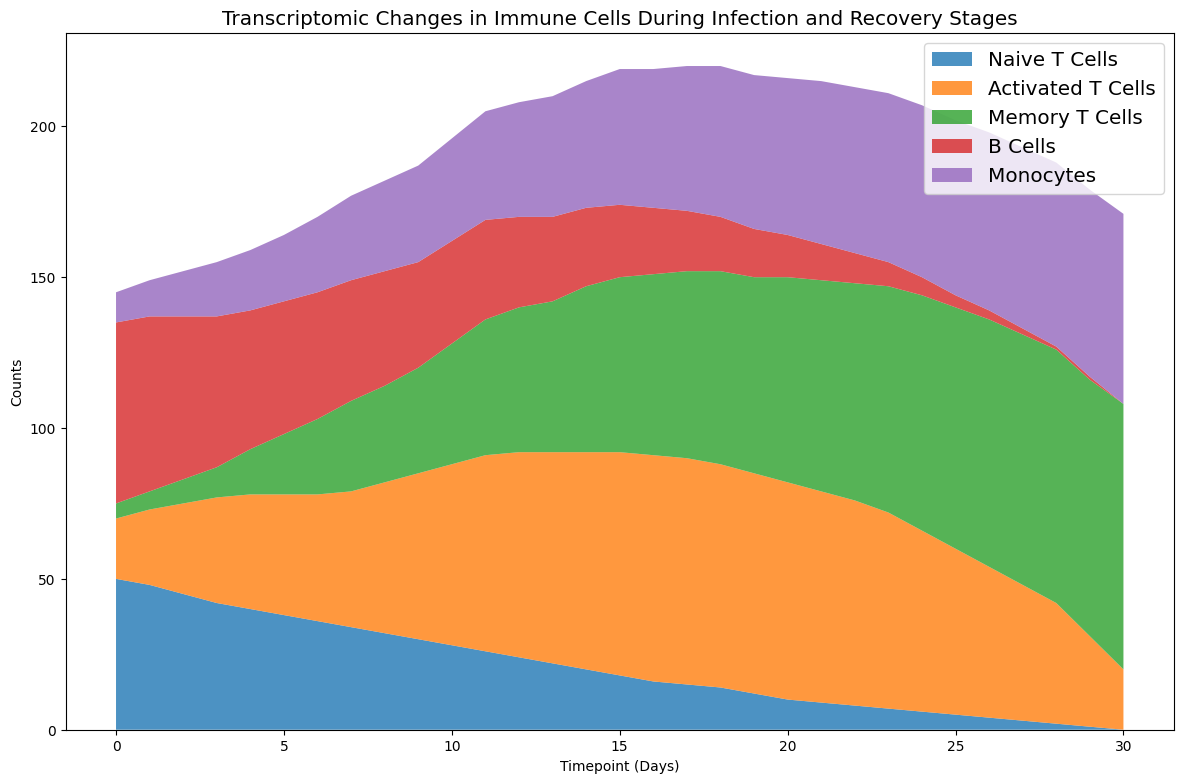What's the overall trend for Naive T Cells from day 0 to day 30? The counts for Naive T Cells gradually decrease from 50 at day 0 to 0 at day 30.
Answer: Decreasing At which timepoint do Activated T Cells reach their maximum count? Activated T Cells reach their highest count of 75 at days 16 and 17.
Answer: Days 16 and 17 Which cell type has the highest count at day 10, and what is its count? At day 10, Activated T Cells have the highest count at 60.
Answer: Activated T Cells, 60 How does the count of B Cells change between day 0 and day 30? B Cells decrease from 60 at day 0 to 0 at day 30.
Answer: Decreasing At what timepoint do Memory T Cells start to outnumber Naive T Cells? Memory T Cells start to outnumber Naive T Cells at day 10, reaching 40 when Naive T Cells are at 28.
Answer: Day 10 Compare the counts of Monocytes and B Cells at day 20. Which cell type is greater? At day 20, the count of Monocytes is 52, while the count of B Cells is 14. Therefore, Monocytes are greater.
Answer: Monocytes What is the sum of all cell counts at day 5? The sum is calculated as 38 + 40 + 20 + 44 + 22 = 164.
Answer: 164 By how much do the counts of Activated T Cells change from day 0 to day 30? Activated T Cells increase from 20 at day 0 to 20 again at day 30.
Answer: 20 What can you observe regarding the relative proportions of Monocytes compared to Naive T Cells over time? Initially, Naive T Cells have a higher count, but Monocytes consistently increase while Naive T Cells decrease. By day 30, Monocytes are higher.
Answer: Monocytes increase while Naive T Cells decrease Which two cell types have the most similar trends in their counts? Activated T Cells and Memory T Cells both show an increasing trend, with Activated T Cells peaking and then slightly stabilizing, while Memory T Cells continue to rise.
Answer: Activated T Cells and Memory T Cells 